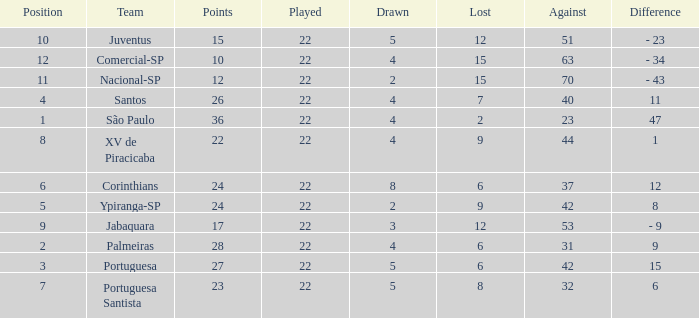Which Played has a Lost larger than 9, and a Points smaller than 15, and a Position smaller than 12, and a Drawn smaller than 2? None. 